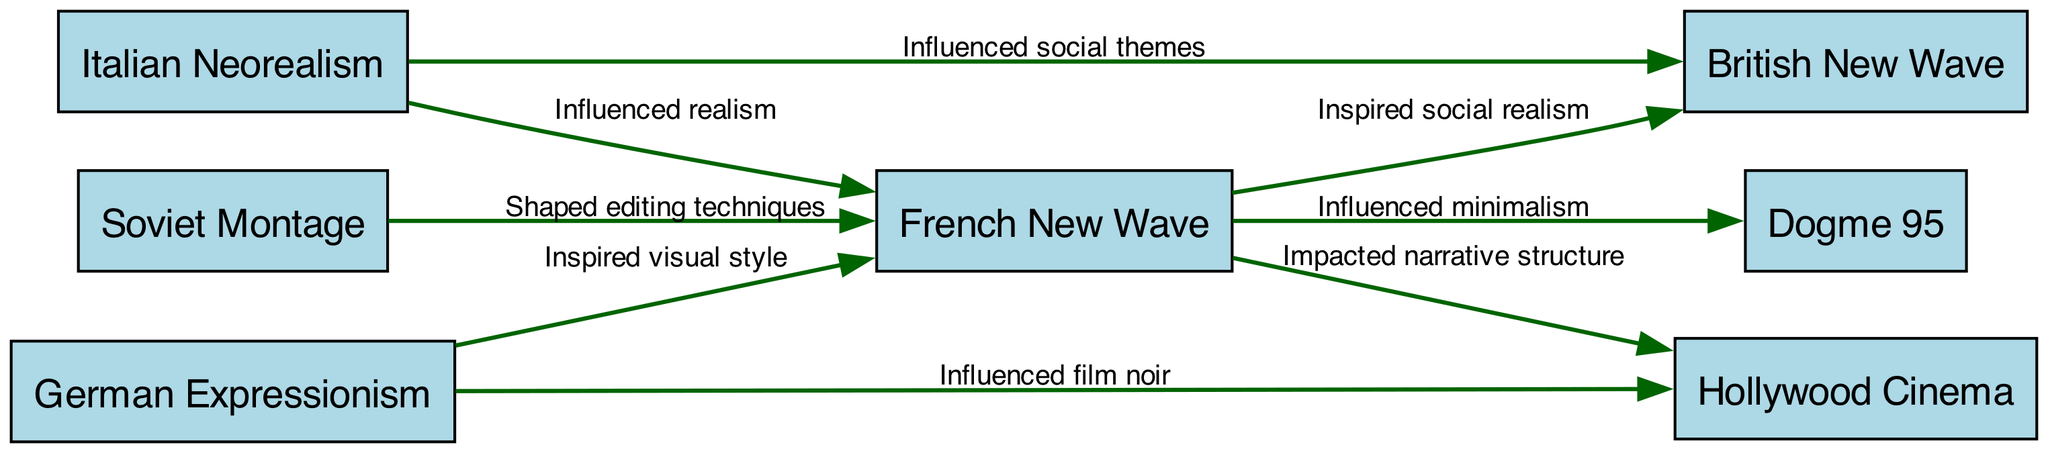What is the total number of nodes in the diagram? The diagram includes the following nodes: French New Wave, Italian Neorealism, German Expressionism, Dogme 95, British New Wave, Soviet Montage, and Hollywood Cinema. Counting these gives a total of 7 nodes.
Answer: 7 Which film movement influenced French New Wave by inspiring visual style? According to the edges in the diagram, German Expressionism is noted to have inspired the visual style of French New Wave.
Answer: German Expressionism How many edges connect to French New Wave? By reviewing the edges in the diagram connected to French New Wave, they are: 1) influenced realism from Italian Neorealism, 2) inspired visual style from German Expressionism, 3) shaped editing techniques from Soviet Montage, 4) inspired social realism in British New Wave, 5) influenced minimalism in Dogme 95, and 6) impacted narrative structure in Hollywood Cinema. This sums up to 6 edges.
Answer: 6 Which movement is impacted by both French New Wave and Italian Neorealism? The British New Wave movement is influenced by both French New Wave (inspired social realism) and Italian Neorealism (influenced social themes) according to the connections depicted in the diagram.
Answer: British New Wave Which film movement has edges leading to Hollywood Cinema? The edges towards Hollywood Cinema come from two film movements: French New Wave, which impacted narrative structure, and German Expressionism, which influenced film noir.
Answer: French New Wave, German Expressionism What is the primary influence of Italian Neorealism on French New Wave? The influence of Italian Neorealism on French New Wave is labeled in the diagram as 'influenced realism,' indicating the nature of this inspiration.
Answer: Influenced realism How many edges originate from French New Wave? The edges originating from French New Wave are: 1) inspired social realism in British New Wave, 2) influenced minimalism in Dogme 95, and 3) impacted narrative structure in Hollywood Cinema. This indicates that there are 3 outgoing edges.
Answer: 3 What is the relationship between German Expressionism and Hollywood Cinema? The diagram shows that German Expressionism influenced Hollywood Cinema specifically in the context of film noir. This edge highlights the relationship between these two movements.
Answer: Influenced film noir 